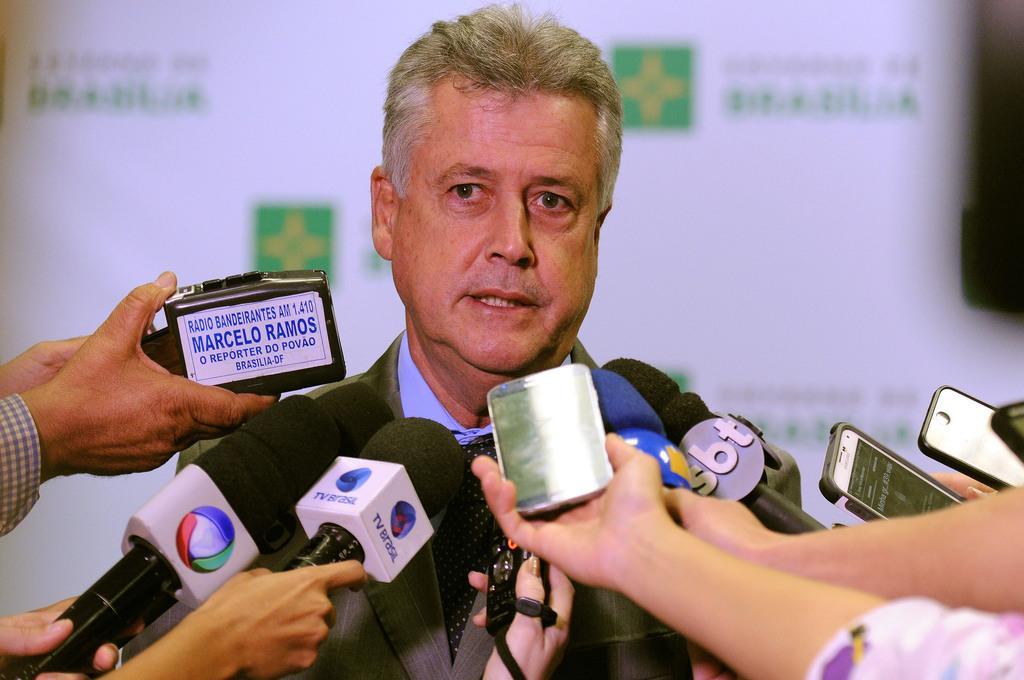Describe this image in one or two sentences. In this picture I can see there is a man standing and he is wearing a blazer and a tie. There are few people standing and holding microphones and smart phones in front of him. In the backdrop there is a banner and there is some symbol and there is something written on it. 